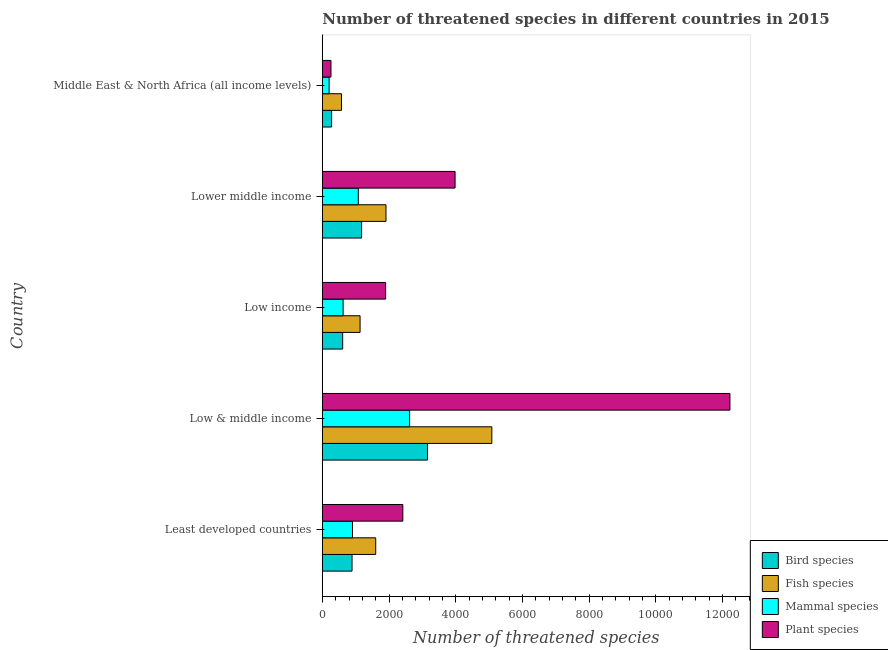Are the number of bars per tick equal to the number of legend labels?
Ensure brevity in your answer.  Yes. How many bars are there on the 2nd tick from the bottom?
Offer a very short reply. 4. What is the label of the 2nd group of bars from the top?
Provide a short and direct response. Lower middle income. In how many cases, is the number of bars for a given country not equal to the number of legend labels?
Provide a succinct answer. 0. What is the number of threatened fish species in Low income?
Give a very brief answer. 1132. Across all countries, what is the maximum number of threatened fish species?
Your response must be concise. 5083. Across all countries, what is the minimum number of threatened mammal species?
Your answer should be very brief. 203. In which country was the number of threatened mammal species minimum?
Your answer should be compact. Middle East & North Africa (all income levels). What is the total number of threatened bird species in the graph?
Offer a terse response. 6112. What is the difference between the number of threatened mammal species in Least developed countries and that in Low income?
Keep it short and to the point. 281. What is the difference between the number of threatened bird species in Low & middle income and the number of threatened fish species in Middle East & North Africa (all income levels)?
Make the answer very short. 2579. What is the average number of threatened fish species per country?
Offer a very short reply. 2060. What is the difference between the number of threatened mammal species and number of threatened plant species in Low & middle income?
Give a very brief answer. -9606. What is the ratio of the number of threatened fish species in Least developed countries to that in Lower middle income?
Ensure brevity in your answer.  0.84. Is the number of threatened fish species in Low & middle income less than that in Lower middle income?
Your response must be concise. No. What is the difference between the highest and the second highest number of threatened bird species?
Offer a very short reply. 1976. What is the difference between the highest and the lowest number of threatened fish species?
Offer a terse response. 4508. Is the sum of the number of threatened fish species in Least developed countries and Low income greater than the maximum number of threatened plant species across all countries?
Your answer should be compact. No. What does the 2nd bar from the top in Lower middle income represents?
Your answer should be very brief. Mammal species. What does the 1st bar from the bottom in Low income represents?
Provide a short and direct response. Bird species. Are the values on the major ticks of X-axis written in scientific E-notation?
Ensure brevity in your answer.  No. Does the graph contain grids?
Offer a very short reply. No. Where does the legend appear in the graph?
Your response must be concise. Bottom right. What is the title of the graph?
Offer a very short reply. Number of threatened species in different countries in 2015. What is the label or title of the X-axis?
Your response must be concise. Number of threatened species. What is the Number of threatened species in Bird species in Least developed countries?
Provide a short and direct response. 891. What is the Number of threatened species in Fish species in Least developed countries?
Provide a short and direct response. 1601. What is the Number of threatened species of Mammal species in Least developed countries?
Provide a short and direct response. 904. What is the Number of threatened species of Plant species in Least developed countries?
Your answer should be very brief. 2414. What is the Number of threatened species of Bird species in Low & middle income?
Make the answer very short. 3154. What is the Number of threatened species of Fish species in Low & middle income?
Give a very brief answer. 5083. What is the Number of threatened species of Mammal species in Low & middle income?
Offer a terse response. 2618. What is the Number of threatened species of Plant species in Low & middle income?
Make the answer very short. 1.22e+04. What is the Number of threatened species in Bird species in Low income?
Offer a terse response. 610. What is the Number of threatened species in Fish species in Low income?
Keep it short and to the point. 1132. What is the Number of threatened species in Mammal species in Low income?
Ensure brevity in your answer.  623. What is the Number of threatened species in Plant species in Low income?
Ensure brevity in your answer.  1898. What is the Number of threatened species in Bird species in Lower middle income?
Give a very brief answer. 1178. What is the Number of threatened species of Fish species in Lower middle income?
Make the answer very short. 1909. What is the Number of threatened species of Mammal species in Lower middle income?
Keep it short and to the point. 1079. What is the Number of threatened species of Plant species in Lower middle income?
Offer a terse response. 3981. What is the Number of threatened species in Bird species in Middle East & North Africa (all income levels)?
Provide a short and direct response. 279. What is the Number of threatened species of Fish species in Middle East & North Africa (all income levels)?
Keep it short and to the point. 575. What is the Number of threatened species of Mammal species in Middle East & North Africa (all income levels)?
Make the answer very short. 203. What is the Number of threatened species of Plant species in Middle East & North Africa (all income levels)?
Offer a terse response. 259. Across all countries, what is the maximum Number of threatened species in Bird species?
Make the answer very short. 3154. Across all countries, what is the maximum Number of threatened species of Fish species?
Your response must be concise. 5083. Across all countries, what is the maximum Number of threatened species of Mammal species?
Your answer should be compact. 2618. Across all countries, what is the maximum Number of threatened species in Plant species?
Provide a short and direct response. 1.22e+04. Across all countries, what is the minimum Number of threatened species of Bird species?
Ensure brevity in your answer.  279. Across all countries, what is the minimum Number of threatened species in Fish species?
Give a very brief answer. 575. Across all countries, what is the minimum Number of threatened species in Mammal species?
Your response must be concise. 203. Across all countries, what is the minimum Number of threatened species in Plant species?
Keep it short and to the point. 259. What is the total Number of threatened species in Bird species in the graph?
Offer a very short reply. 6112. What is the total Number of threatened species of Fish species in the graph?
Keep it short and to the point. 1.03e+04. What is the total Number of threatened species in Mammal species in the graph?
Give a very brief answer. 5427. What is the total Number of threatened species of Plant species in the graph?
Your response must be concise. 2.08e+04. What is the difference between the Number of threatened species of Bird species in Least developed countries and that in Low & middle income?
Offer a terse response. -2263. What is the difference between the Number of threatened species of Fish species in Least developed countries and that in Low & middle income?
Provide a short and direct response. -3482. What is the difference between the Number of threatened species of Mammal species in Least developed countries and that in Low & middle income?
Give a very brief answer. -1714. What is the difference between the Number of threatened species in Plant species in Least developed countries and that in Low & middle income?
Offer a very short reply. -9810. What is the difference between the Number of threatened species of Bird species in Least developed countries and that in Low income?
Offer a terse response. 281. What is the difference between the Number of threatened species in Fish species in Least developed countries and that in Low income?
Offer a very short reply. 469. What is the difference between the Number of threatened species in Mammal species in Least developed countries and that in Low income?
Keep it short and to the point. 281. What is the difference between the Number of threatened species of Plant species in Least developed countries and that in Low income?
Offer a terse response. 516. What is the difference between the Number of threatened species in Bird species in Least developed countries and that in Lower middle income?
Provide a short and direct response. -287. What is the difference between the Number of threatened species in Fish species in Least developed countries and that in Lower middle income?
Offer a terse response. -308. What is the difference between the Number of threatened species in Mammal species in Least developed countries and that in Lower middle income?
Give a very brief answer. -175. What is the difference between the Number of threatened species of Plant species in Least developed countries and that in Lower middle income?
Your response must be concise. -1567. What is the difference between the Number of threatened species of Bird species in Least developed countries and that in Middle East & North Africa (all income levels)?
Make the answer very short. 612. What is the difference between the Number of threatened species of Fish species in Least developed countries and that in Middle East & North Africa (all income levels)?
Your answer should be very brief. 1026. What is the difference between the Number of threatened species of Mammal species in Least developed countries and that in Middle East & North Africa (all income levels)?
Provide a short and direct response. 701. What is the difference between the Number of threatened species of Plant species in Least developed countries and that in Middle East & North Africa (all income levels)?
Keep it short and to the point. 2155. What is the difference between the Number of threatened species of Bird species in Low & middle income and that in Low income?
Offer a very short reply. 2544. What is the difference between the Number of threatened species of Fish species in Low & middle income and that in Low income?
Your answer should be very brief. 3951. What is the difference between the Number of threatened species in Mammal species in Low & middle income and that in Low income?
Ensure brevity in your answer.  1995. What is the difference between the Number of threatened species in Plant species in Low & middle income and that in Low income?
Give a very brief answer. 1.03e+04. What is the difference between the Number of threatened species of Bird species in Low & middle income and that in Lower middle income?
Offer a very short reply. 1976. What is the difference between the Number of threatened species in Fish species in Low & middle income and that in Lower middle income?
Keep it short and to the point. 3174. What is the difference between the Number of threatened species in Mammal species in Low & middle income and that in Lower middle income?
Offer a very short reply. 1539. What is the difference between the Number of threatened species in Plant species in Low & middle income and that in Lower middle income?
Provide a succinct answer. 8243. What is the difference between the Number of threatened species of Bird species in Low & middle income and that in Middle East & North Africa (all income levels)?
Ensure brevity in your answer.  2875. What is the difference between the Number of threatened species of Fish species in Low & middle income and that in Middle East & North Africa (all income levels)?
Give a very brief answer. 4508. What is the difference between the Number of threatened species in Mammal species in Low & middle income and that in Middle East & North Africa (all income levels)?
Give a very brief answer. 2415. What is the difference between the Number of threatened species of Plant species in Low & middle income and that in Middle East & North Africa (all income levels)?
Offer a very short reply. 1.20e+04. What is the difference between the Number of threatened species in Bird species in Low income and that in Lower middle income?
Your answer should be compact. -568. What is the difference between the Number of threatened species in Fish species in Low income and that in Lower middle income?
Keep it short and to the point. -777. What is the difference between the Number of threatened species in Mammal species in Low income and that in Lower middle income?
Provide a short and direct response. -456. What is the difference between the Number of threatened species of Plant species in Low income and that in Lower middle income?
Make the answer very short. -2083. What is the difference between the Number of threatened species in Bird species in Low income and that in Middle East & North Africa (all income levels)?
Provide a succinct answer. 331. What is the difference between the Number of threatened species in Fish species in Low income and that in Middle East & North Africa (all income levels)?
Provide a succinct answer. 557. What is the difference between the Number of threatened species in Mammal species in Low income and that in Middle East & North Africa (all income levels)?
Your answer should be compact. 420. What is the difference between the Number of threatened species of Plant species in Low income and that in Middle East & North Africa (all income levels)?
Ensure brevity in your answer.  1639. What is the difference between the Number of threatened species of Bird species in Lower middle income and that in Middle East & North Africa (all income levels)?
Offer a terse response. 899. What is the difference between the Number of threatened species in Fish species in Lower middle income and that in Middle East & North Africa (all income levels)?
Give a very brief answer. 1334. What is the difference between the Number of threatened species of Mammal species in Lower middle income and that in Middle East & North Africa (all income levels)?
Provide a short and direct response. 876. What is the difference between the Number of threatened species of Plant species in Lower middle income and that in Middle East & North Africa (all income levels)?
Keep it short and to the point. 3722. What is the difference between the Number of threatened species in Bird species in Least developed countries and the Number of threatened species in Fish species in Low & middle income?
Make the answer very short. -4192. What is the difference between the Number of threatened species in Bird species in Least developed countries and the Number of threatened species in Mammal species in Low & middle income?
Keep it short and to the point. -1727. What is the difference between the Number of threatened species in Bird species in Least developed countries and the Number of threatened species in Plant species in Low & middle income?
Provide a short and direct response. -1.13e+04. What is the difference between the Number of threatened species of Fish species in Least developed countries and the Number of threatened species of Mammal species in Low & middle income?
Your answer should be very brief. -1017. What is the difference between the Number of threatened species in Fish species in Least developed countries and the Number of threatened species in Plant species in Low & middle income?
Provide a succinct answer. -1.06e+04. What is the difference between the Number of threatened species of Mammal species in Least developed countries and the Number of threatened species of Plant species in Low & middle income?
Your response must be concise. -1.13e+04. What is the difference between the Number of threatened species in Bird species in Least developed countries and the Number of threatened species in Fish species in Low income?
Ensure brevity in your answer.  -241. What is the difference between the Number of threatened species in Bird species in Least developed countries and the Number of threatened species in Mammal species in Low income?
Give a very brief answer. 268. What is the difference between the Number of threatened species of Bird species in Least developed countries and the Number of threatened species of Plant species in Low income?
Make the answer very short. -1007. What is the difference between the Number of threatened species of Fish species in Least developed countries and the Number of threatened species of Mammal species in Low income?
Your answer should be compact. 978. What is the difference between the Number of threatened species of Fish species in Least developed countries and the Number of threatened species of Plant species in Low income?
Give a very brief answer. -297. What is the difference between the Number of threatened species in Mammal species in Least developed countries and the Number of threatened species in Plant species in Low income?
Your response must be concise. -994. What is the difference between the Number of threatened species of Bird species in Least developed countries and the Number of threatened species of Fish species in Lower middle income?
Ensure brevity in your answer.  -1018. What is the difference between the Number of threatened species of Bird species in Least developed countries and the Number of threatened species of Mammal species in Lower middle income?
Your answer should be compact. -188. What is the difference between the Number of threatened species of Bird species in Least developed countries and the Number of threatened species of Plant species in Lower middle income?
Your answer should be compact. -3090. What is the difference between the Number of threatened species of Fish species in Least developed countries and the Number of threatened species of Mammal species in Lower middle income?
Your response must be concise. 522. What is the difference between the Number of threatened species of Fish species in Least developed countries and the Number of threatened species of Plant species in Lower middle income?
Offer a very short reply. -2380. What is the difference between the Number of threatened species of Mammal species in Least developed countries and the Number of threatened species of Plant species in Lower middle income?
Your answer should be compact. -3077. What is the difference between the Number of threatened species in Bird species in Least developed countries and the Number of threatened species in Fish species in Middle East & North Africa (all income levels)?
Your answer should be compact. 316. What is the difference between the Number of threatened species in Bird species in Least developed countries and the Number of threatened species in Mammal species in Middle East & North Africa (all income levels)?
Offer a very short reply. 688. What is the difference between the Number of threatened species of Bird species in Least developed countries and the Number of threatened species of Plant species in Middle East & North Africa (all income levels)?
Provide a succinct answer. 632. What is the difference between the Number of threatened species of Fish species in Least developed countries and the Number of threatened species of Mammal species in Middle East & North Africa (all income levels)?
Your answer should be compact. 1398. What is the difference between the Number of threatened species of Fish species in Least developed countries and the Number of threatened species of Plant species in Middle East & North Africa (all income levels)?
Offer a terse response. 1342. What is the difference between the Number of threatened species in Mammal species in Least developed countries and the Number of threatened species in Plant species in Middle East & North Africa (all income levels)?
Give a very brief answer. 645. What is the difference between the Number of threatened species of Bird species in Low & middle income and the Number of threatened species of Fish species in Low income?
Make the answer very short. 2022. What is the difference between the Number of threatened species in Bird species in Low & middle income and the Number of threatened species in Mammal species in Low income?
Provide a short and direct response. 2531. What is the difference between the Number of threatened species of Bird species in Low & middle income and the Number of threatened species of Plant species in Low income?
Offer a very short reply. 1256. What is the difference between the Number of threatened species of Fish species in Low & middle income and the Number of threatened species of Mammal species in Low income?
Your response must be concise. 4460. What is the difference between the Number of threatened species in Fish species in Low & middle income and the Number of threatened species in Plant species in Low income?
Give a very brief answer. 3185. What is the difference between the Number of threatened species in Mammal species in Low & middle income and the Number of threatened species in Plant species in Low income?
Ensure brevity in your answer.  720. What is the difference between the Number of threatened species of Bird species in Low & middle income and the Number of threatened species of Fish species in Lower middle income?
Give a very brief answer. 1245. What is the difference between the Number of threatened species in Bird species in Low & middle income and the Number of threatened species in Mammal species in Lower middle income?
Make the answer very short. 2075. What is the difference between the Number of threatened species in Bird species in Low & middle income and the Number of threatened species in Plant species in Lower middle income?
Your response must be concise. -827. What is the difference between the Number of threatened species in Fish species in Low & middle income and the Number of threatened species in Mammal species in Lower middle income?
Give a very brief answer. 4004. What is the difference between the Number of threatened species in Fish species in Low & middle income and the Number of threatened species in Plant species in Lower middle income?
Ensure brevity in your answer.  1102. What is the difference between the Number of threatened species of Mammal species in Low & middle income and the Number of threatened species of Plant species in Lower middle income?
Your answer should be very brief. -1363. What is the difference between the Number of threatened species of Bird species in Low & middle income and the Number of threatened species of Fish species in Middle East & North Africa (all income levels)?
Give a very brief answer. 2579. What is the difference between the Number of threatened species in Bird species in Low & middle income and the Number of threatened species in Mammal species in Middle East & North Africa (all income levels)?
Ensure brevity in your answer.  2951. What is the difference between the Number of threatened species of Bird species in Low & middle income and the Number of threatened species of Plant species in Middle East & North Africa (all income levels)?
Give a very brief answer. 2895. What is the difference between the Number of threatened species in Fish species in Low & middle income and the Number of threatened species in Mammal species in Middle East & North Africa (all income levels)?
Offer a very short reply. 4880. What is the difference between the Number of threatened species of Fish species in Low & middle income and the Number of threatened species of Plant species in Middle East & North Africa (all income levels)?
Ensure brevity in your answer.  4824. What is the difference between the Number of threatened species of Mammal species in Low & middle income and the Number of threatened species of Plant species in Middle East & North Africa (all income levels)?
Your answer should be compact. 2359. What is the difference between the Number of threatened species in Bird species in Low income and the Number of threatened species in Fish species in Lower middle income?
Your answer should be compact. -1299. What is the difference between the Number of threatened species in Bird species in Low income and the Number of threatened species in Mammal species in Lower middle income?
Ensure brevity in your answer.  -469. What is the difference between the Number of threatened species of Bird species in Low income and the Number of threatened species of Plant species in Lower middle income?
Offer a very short reply. -3371. What is the difference between the Number of threatened species of Fish species in Low income and the Number of threatened species of Plant species in Lower middle income?
Your answer should be compact. -2849. What is the difference between the Number of threatened species of Mammal species in Low income and the Number of threatened species of Plant species in Lower middle income?
Offer a very short reply. -3358. What is the difference between the Number of threatened species in Bird species in Low income and the Number of threatened species in Fish species in Middle East & North Africa (all income levels)?
Your answer should be very brief. 35. What is the difference between the Number of threatened species in Bird species in Low income and the Number of threatened species in Mammal species in Middle East & North Africa (all income levels)?
Keep it short and to the point. 407. What is the difference between the Number of threatened species of Bird species in Low income and the Number of threatened species of Plant species in Middle East & North Africa (all income levels)?
Give a very brief answer. 351. What is the difference between the Number of threatened species in Fish species in Low income and the Number of threatened species in Mammal species in Middle East & North Africa (all income levels)?
Your answer should be compact. 929. What is the difference between the Number of threatened species of Fish species in Low income and the Number of threatened species of Plant species in Middle East & North Africa (all income levels)?
Ensure brevity in your answer.  873. What is the difference between the Number of threatened species in Mammal species in Low income and the Number of threatened species in Plant species in Middle East & North Africa (all income levels)?
Provide a short and direct response. 364. What is the difference between the Number of threatened species of Bird species in Lower middle income and the Number of threatened species of Fish species in Middle East & North Africa (all income levels)?
Give a very brief answer. 603. What is the difference between the Number of threatened species of Bird species in Lower middle income and the Number of threatened species of Mammal species in Middle East & North Africa (all income levels)?
Offer a terse response. 975. What is the difference between the Number of threatened species in Bird species in Lower middle income and the Number of threatened species in Plant species in Middle East & North Africa (all income levels)?
Make the answer very short. 919. What is the difference between the Number of threatened species of Fish species in Lower middle income and the Number of threatened species of Mammal species in Middle East & North Africa (all income levels)?
Ensure brevity in your answer.  1706. What is the difference between the Number of threatened species of Fish species in Lower middle income and the Number of threatened species of Plant species in Middle East & North Africa (all income levels)?
Ensure brevity in your answer.  1650. What is the difference between the Number of threatened species in Mammal species in Lower middle income and the Number of threatened species in Plant species in Middle East & North Africa (all income levels)?
Make the answer very short. 820. What is the average Number of threatened species in Bird species per country?
Your response must be concise. 1222.4. What is the average Number of threatened species of Fish species per country?
Provide a succinct answer. 2060. What is the average Number of threatened species of Mammal species per country?
Your answer should be very brief. 1085.4. What is the average Number of threatened species of Plant species per country?
Provide a succinct answer. 4155.2. What is the difference between the Number of threatened species of Bird species and Number of threatened species of Fish species in Least developed countries?
Provide a succinct answer. -710. What is the difference between the Number of threatened species of Bird species and Number of threatened species of Plant species in Least developed countries?
Give a very brief answer. -1523. What is the difference between the Number of threatened species of Fish species and Number of threatened species of Mammal species in Least developed countries?
Keep it short and to the point. 697. What is the difference between the Number of threatened species of Fish species and Number of threatened species of Plant species in Least developed countries?
Your answer should be very brief. -813. What is the difference between the Number of threatened species in Mammal species and Number of threatened species in Plant species in Least developed countries?
Your response must be concise. -1510. What is the difference between the Number of threatened species in Bird species and Number of threatened species in Fish species in Low & middle income?
Offer a terse response. -1929. What is the difference between the Number of threatened species of Bird species and Number of threatened species of Mammal species in Low & middle income?
Give a very brief answer. 536. What is the difference between the Number of threatened species in Bird species and Number of threatened species in Plant species in Low & middle income?
Provide a succinct answer. -9070. What is the difference between the Number of threatened species in Fish species and Number of threatened species in Mammal species in Low & middle income?
Make the answer very short. 2465. What is the difference between the Number of threatened species of Fish species and Number of threatened species of Plant species in Low & middle income?
Ensure brevity in your answer.  -7141. What is the difference between the Number of threatened species of Mammal species and Number of threatened species of Plant species in Low & middle income?
Keep it short and to the point. -9606. What is the difference between the Number of threatened species in Bird species and Number of threatened species in Fish species in Low income?
Give a very brief answer. -522. What is the difference between the Number of threatened species of Bird species and Number of threatened species of Mammal species in Low income?
Ensure brevity in your answer.  -13. What is the difference between the Number of threatened species of Bird species and Number of threatened species of Plant species in Low income?
Your answer should be compact. -1288. What is the difference between the Number of threatened species in Fish species and Number of threatened species in Mammal species in Low income?
Keep it short and to the point. 509. What is the difference between the Number of threatened species in Fish species and Number of threatened species in Plant species in Low income?
Ensure brevity in your answer.  -766. What is the difference between the Number of threatened species in Mammal species and Number of threatened species in Plant species in Low income?
Offer a very short reply. -1275. What is the difference between the Number of threatened species in Bird species and Number of threatened species in Fish species in Lower middle income?
Offer a terse response. -731. What is the difference between the Number of threatened species in Bird species and Number of threatened species in Plant species in Lower middle income?
Give a very brief answer. -2803. What is the difference between the Number of threatened species of Fish species and Number of threatened species of Mammal species in Lower middle income?
Your answer should be compact. 830. What is the difference between the Number of threatened species of Fish species and Number of threatened species of Plant species in Lower middle income?
Offer a terse response. -2072. What is the difference between the Number of threatened species in Mammal species and Number of threatened species in Plant species in Lower middle income?
Your answer should be very brief. -2902. What is the difference between the Number of threatened species in Bird species and Number of threatened species in Fish species in Middle East & North Africa (all income levels)?
Offer a very short reply. -296. What is the difference between the Number of threatened species in Bird species and Number of threatened species in Plant species in Middle East & North Africa (all income levels)?
Provide a succinct answer. 20. What is the difference between the Number of threatened species in Fish species and Number of threatened species in Mammal species in Middle East & North Africa (all income levels)?
Make the answer very short. 372. What is the difference between the Number of threatened species of Fish species and Number of threatened species of Plant species in Middle East & North Africa (all income levels)?
Your response must be concise. 316. What is the difference between the Number of threatened species of Mammal species and Number of threatened species of Plant species in Middle East & North Africa (all income levels)?
Your answer should be compact. -56. What is the ratio of the Number of threatened species in Bird species in Least developed countries to that in Low & middle income?
Keep it short and to the point. 0.28. What is the ratio of the Number of threatened species of Fish species in Least developed countries to that in Low & middle income?
Keep it short and to the point. 0.32. What is the ratio of the Number of threatened species in Mammal species in Least developed countries to that in Low & middle income?
Provide a short and direct response. 0.35. What is the ratio of the Number of threatened species in Plant species in Least developed countries to that in Low & middle income?
Your answer should be very brief. 0.2. What is the ratio of the Number of threatened species in Bird species in Least developed countries to that in Low income?
Provide a short and direct response. 1.46. What is the ratio of the Number of threatened species in Fish species in Least developed countries to that in Low income?
Offer a very short reply. 1.41. What is the ratio of the Number of threatened species in Mammal species in Least developed countries to that in Low income?
Your answer should be compact. 1.45. What is the ratio of the Number of threatened species in Plant species in Least developed countries to that in Low income?
Your answer should be very brief. 1.27. What is the ratio of the Number of threatened species in Bird species in Least developed countries to that in Lower middle income?
Offer a very short reply. 0.76. What is the ratio of the Number of threatened species of Fish species in Least developed countries to that in Lower middle income?
Ensure brevity in your answer.  0.84. What is the ratio of the Number of threatened species in Mammal species in Least developed countries to that in Lower middle income?
Offer a terse response. 0.84. What is the ratio of the Number of threatened species in Plant species in Least developed countries to that in Lower middle income?
Provide a succinct answer. 0.61. What is the ratio of the Number of threatened species in Bird species in Least developed countries to that in Middle East & North Africa (all income levels)?
Offer a terse response. 3.19. What is the ratio of the Number of threatened species of Fish species in Least developed countries to that in Middle East & North Africa (all income levels)?
Provide a short and direct response. 2.78. What is the ratio of the Number of threatened species of Mammal species in Least developed countries to that in Middle East & North Africa (all income levels)?
Offer a very short reply. 4.45. What is the ratio of the Number of threatened species in Plant species in Least developed countries to that in Middle East & North Africa (all income levels)?
Your answer should be very brief. 9.32. What is the ratio of the Number of threatened species in Bird species in Low & middle income to that in Low income?
Give a very brief answer. 5.17. What is the ratio of the Number of threatened species in Fish species in Low & middle income to that in Low income?
Your answer should be very brief. 4.49. What is the ratio of the Number of threatened species in Mammal species in Low & middle income to that in Low income?
Give a very brief answer. 4.2. What is the ratio of the Number of threatened species of Plant species in Low & middle income to that in Low income?
Make the answer very short. 6.44. What is the ratio of the Number of threatened species of Bird species in Low & middle income to that in Lower middle income?
Your answer should be very brief. 2.68. What is the ratio of the Number of threatened species in Fish species in Low & middle income to that in Lower middle income?
Your answer should be very brief. 2.66. What is the ratio of the Number of threatened species of Mammal species in Low & middle income to that in Lower middle income?
Make the answer very short. 2.43. What is the ratio of the Number of threatened species of Plant species in Low & middle income to that in Lower middle income?
Your response must be concise. 3.07. What is the ratio of the Number of threatened species of Bird species in Low & middle income to that in Middle East & North Africa (all income levels)?
Make the answer very short. 11.3. What is the ratio of the Number of threatened species of Fish species in Low & middle income to that in Middle East & North Africa (all income levels)?
Your answer should be very brief. 8.84. What is the ratio of the Number of threatened species in Mammal species in Low & middle income to that in Middle East & North Africa (all income levels)?
Provide a succinct answer. 12.9. What is the ratio of the Number of threatened species of Plant species in Low & middle income to that in Middle East & North Africa (all income levels)?
Offer a terse response. 47.2. What is the ratio of the Number of threatened species in Bird species in Low income to that in Lower middle income?
Offer a very short reply. 0.52. What is the ratio of the Number of threatened species of Fish species in Low income to that in Lower middle income?
Offer a very short reply. 0.59. What is the ratio of the Number of threatened species of Mammal species in Low income to that in Lower middle income?
Your answer should be compact. 0.58. What is the ratio of the Number of threatened species in Plant species in Low income to that in Lower middle income?
Keep it short and to the point. 0.48. What is the ratio of the Number of threatened species of Bird species in Low income to that in Middle East & North Africa (all income levels)?
Offer a very short reply. 2.19. What is the ratio of the Number of threatened species in Fish species in Low income to that in Middle East & North Africa (all income levels)?
Offer a very short reply. 1.97. What is the ratio of the Number of threatened species of Mammal species in Low income to that in Middle East & North Africa (all income levels)?
Your response must be concise. 3.07. What is the ratio of the Number of threatened species of Plant species in Low income to that in Middle East & North Africa (all income levels)?
Offer a very short reply. 7.33. What is the ratio of the Number of threatened species in Bird species in Lower middle income to that in Middle East & North Africa (all income levels)?
Ensure brevity in your answer.  4.22. What is the ratio of the Number of threatened species of Fish species in Lower middle income to that in Middle East & North Africa (all income levels)?
Give a very brief answer. 3.32. What is the ratio of the Number of threatened species of Mammal species in Lower middle income to that in Middle East & North Africa (all income levels)?
Make the answer very short. 5.32. What is the ratio of the Number of threatened species of Plant species in Lower middle income to that in Middle East & North Africa (all income levels)?
Give a very brief answer. 15.37. What is the difference between the highest and the second highest Number of threatened species of Bird species?
Your answer should be compact. 1976. What is the difference between the highest and the second highest Number of threatened species in Fish species?
Keep it short and to the point. 3174. What is the difference between the highest and the second highest Number of threatened species in Mammal species?
Your response must be concise. 1539. What is the difference between the highest and the second highest Number of threatened species in Plant species?
Ensure brevity in your answer.  8243. What is the difference between the highest and the lowest Number of threatened species of Bird species?
Give a very brief answer. 2875. What is the difference between the highest and the lowest Number of threatened species of Fish species?
Offer a very short reply. 4508. What is the difference between the highest and the lowest Number of threatened species of Mammal species?
Give a very brief answer. 2415. What is the difference between the highest and the lowest Number of threatened species of Plant species?
Your answer should be very brief. 1.20e+04. 